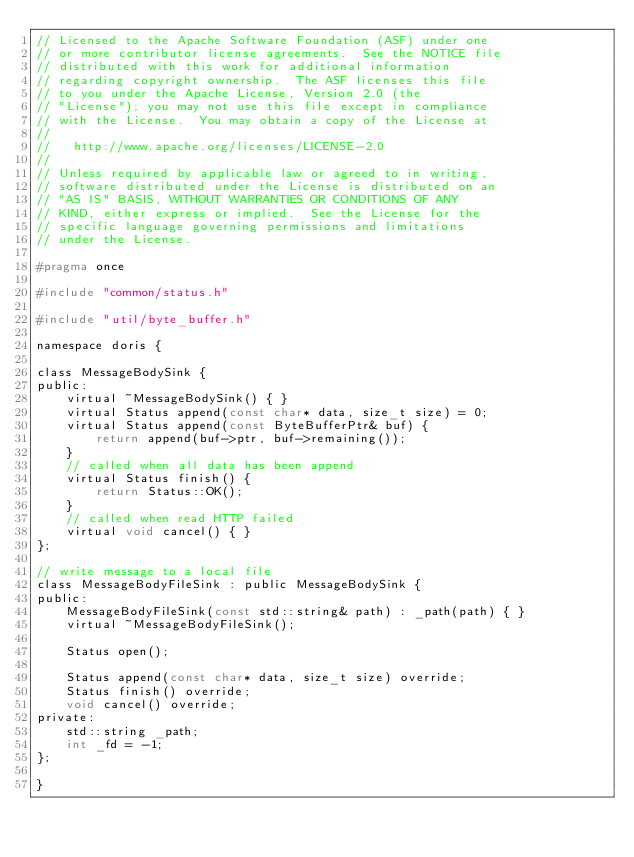Convert code to text. <code><loc_0><loc_0><loc_500><loc_500><_C_>// Licensed to the Apache Software Foundation (ASF) under one
// or more contributor license agreements.  See the NOTICE file
// distributed with this work for additional information
// regarding copyright ownership.  The ASF licenses this file
// to you under the Apache License, Version 2.0 (the
// "License"); you may not use this file except in compliance
// with the License.  You may obtain a copy of the License at
//
//   http://www.apache.org/licenses/LICENSE-2.0
//
// Unless required by applicable law or agreed to in writing,
// software distributed under the License is distributed on an
// "AS IS" BASIS, WITHOUT WARRANTIES OR CONDITIONS OF ANY
// KIND, either express or implied.  See the License for the
// specific language governing permissions and limitations
// under the License.

#pragma once

#include "common/status.h"

#include "util/byte_buffer.h"

namespace doris {

class MessageBodySink {
public:
    virtual ~MessageBodySink() { }
    virtual Status append(const char* data, size_t size) = 0;
    virtual Status append(const ByteBufferPtr& buf) {
        return append(buf->ptr, buf->remaining());
    }
    // called when all data has been append
    virtual Status finish() {
        return Status::OK();
    }
    // called when read HTTP failed
    virtual void cancel() { }
};

// write message to a local file
class MessageBodyFileSink : public MessageBodySink {
public:
    MessageBodyFileSink(const std::string& path) : _path(path) { }
    virtual ~MessageBodyFileSink();

    Status open();

    Status append(const char* data, size_t size) override;
    Status finish() override;
    void cancel() override;
private:
    std::string _path;
    int _fd = -1;
};

}
</code> 